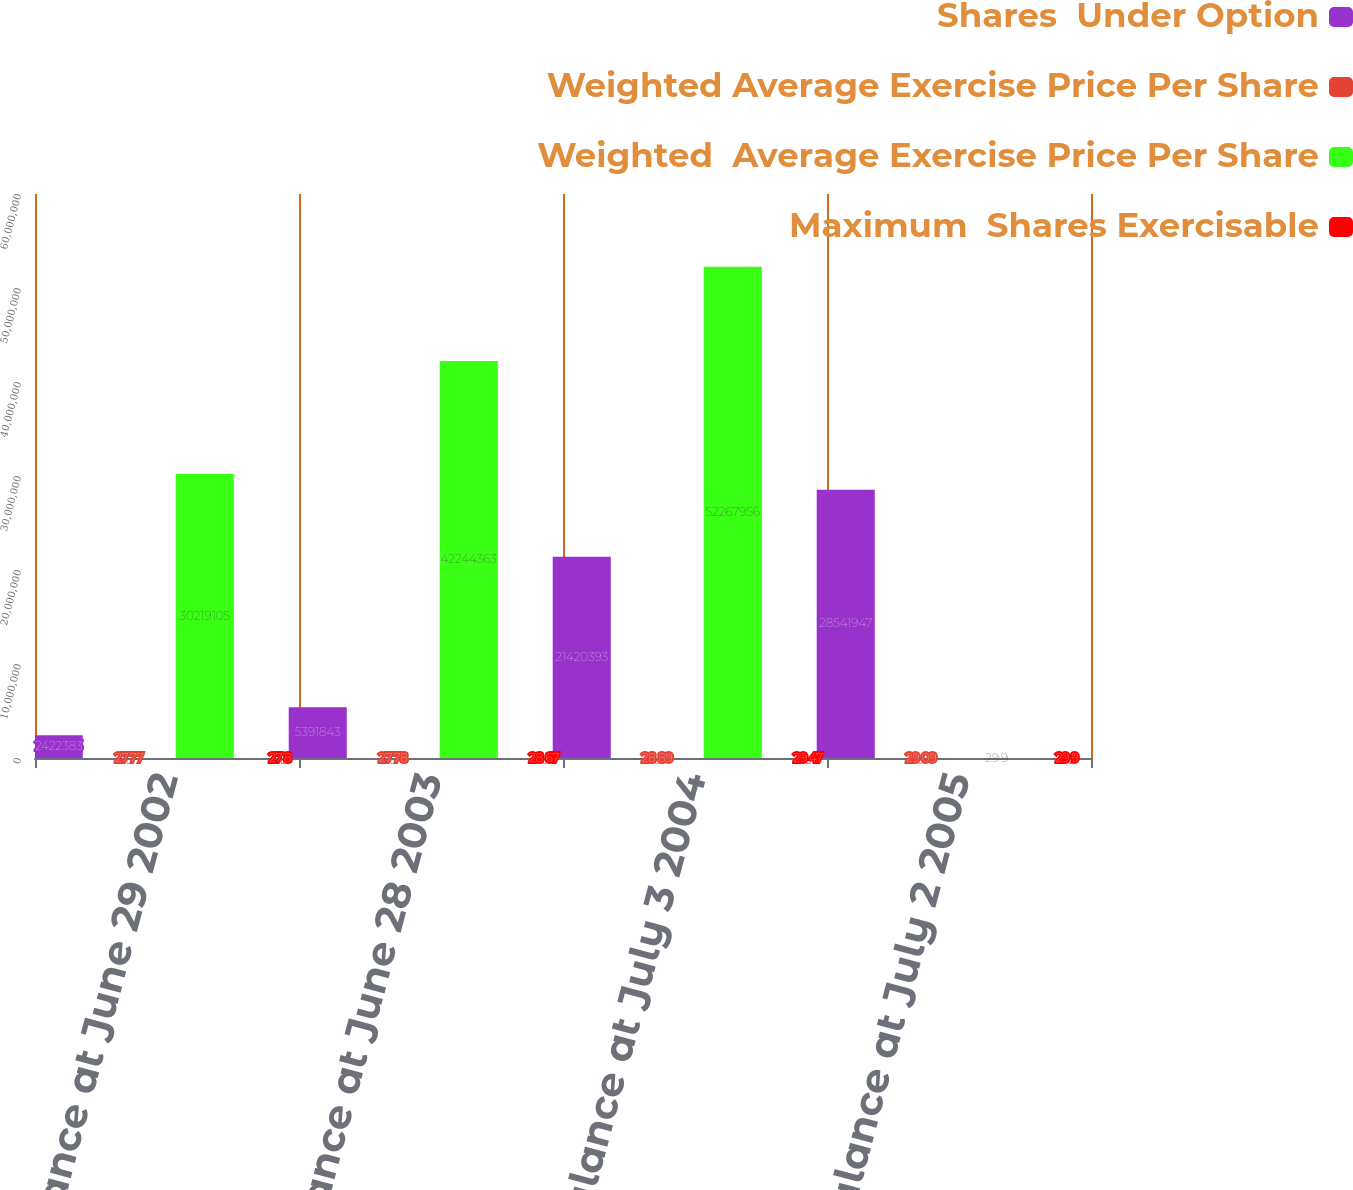Convert chart. <chart><loc_0><loc_0><loc_500><loc_500><stacked_bar_chart><ecel><fcel>Balance at June 29 2002<fcel>Balance at June 28 2003<fcel>Balance at July 3 2004<fcel>Balance at July 2 2005<nl><fcel>Shares  Under Option<fcel>2.42238e+06<fcel>5.39184e+06<fcel>2.14204e+07<fcel>2.85419e+07<nl><fcel>Weighted Average Exercise Price Per Share<fcel>27.77<fcel>27.78<fcel>28.89<fcel>29.09<nl><fcel>Weighted  Average Exercise Price Per Share<fcel>3.02191e+07<fcel>4.22444e+07<fcel>5.2268e+07<fcel>29.9<nl><fcel>Maximum  Shares Exercisable<fcel>27.8<fcel>28.67<fcel>29.47<fcel>29.9<nl></chart> 